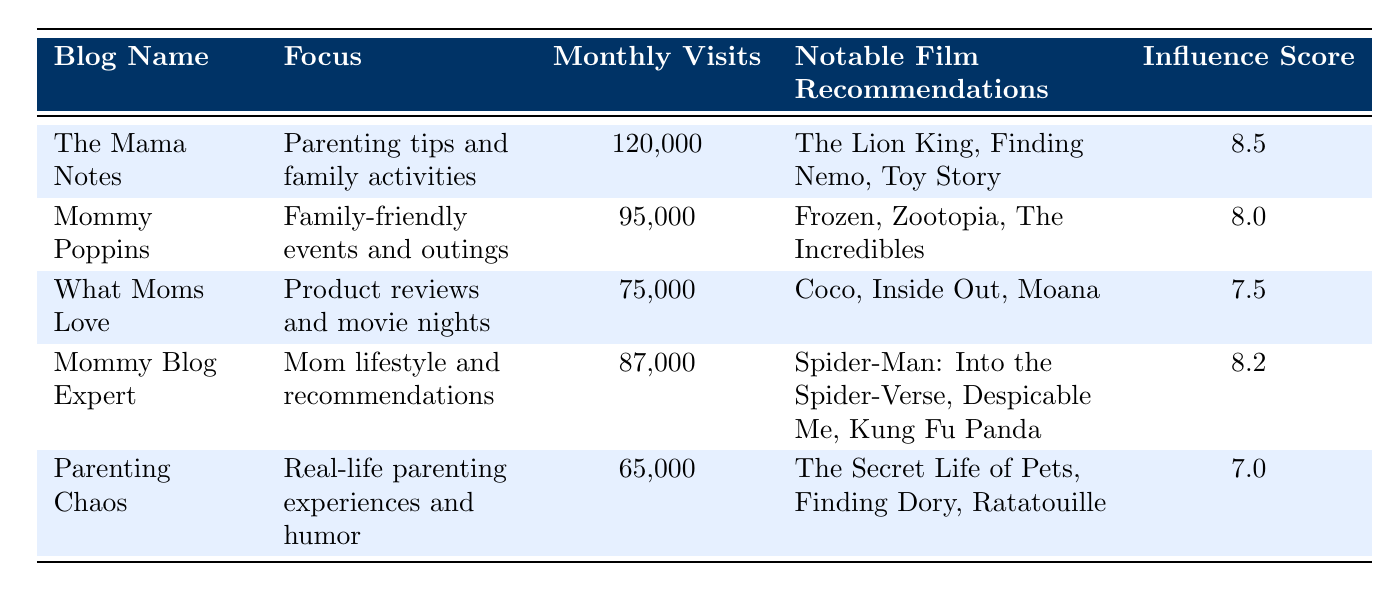What is the influence score of "The Mama Notes"? The influence score for "The Mama Notes" is listed in the table under the Influence Score column. It shows a value of 8.5.
Answer: 8.5 Which blog has the highest average monthly visits? By comparing the values in the Average Monthly Visits column, "The Mama Notes" has the highest value of 120,000 visits per month.
Answer: The Mama Notes Is "Coco" a notable film recommendation on "Mommy Poppins"? Checking the Notable Film Recommendations column for "Mommy Poppins," the recommended films are "Frozen," "Zootopia," and "The Incredibles," which do not include "Coco."
Answer: No What is the average influence score of all the blogs listed? To find the average influence score, sum the scores (8.5 + 8.0 + 7.5 + 8.2 + 7.0 = 39.2) and divide by the number of blogs (5). Thus, the average is 39.2 / 5 = 7.84.
Answer: 7.84 How many blogs have an influence score above 8.0? By examining the Influence Score column, "The Mama Notes" (8.5), "Mommy Poppins" (8.0), and "Mommy Blog Expert" (8.2) all have scores at or above 8.0. Therefore, there are 3 blogs in total that meet this criterion.
Answer: 3 What is the total number of average monthly visits for blogs with a focus on parenting tips? There is one blog focusing on parenting tips, which is "The Mama Notes" with 120,000 visits. Thus, the total number of average monthly visits for this category is simply 120,000.
Answer: 120,000 Which blog focuses on product reviews and movie nights? Referring to the Focus column, "What Moms Love" is identified as the blog that focuses on product reviews and movie nights.
Answer: What Moms Love Does the "Parenting Chaos" blog have more average monthly visits than "What Moms Love"? The average monthly visits for "Parenting Chaos" is 65,000 and for "What Moms Love" it is 75,000. Since 65,000 is less than 75,000, the answer is that "Parenting Chaos" does not have more visits.
Answer: No How many notable film recommendations are provided by "Mommy Blog Expert"? The table lists three notable film recommendations under "Mommy Blog Expert": "Spider-Man: Into the Spider-Verse," "Despicable Me," and "Kung Fu Panda," so the total is three.
Answer: 3 